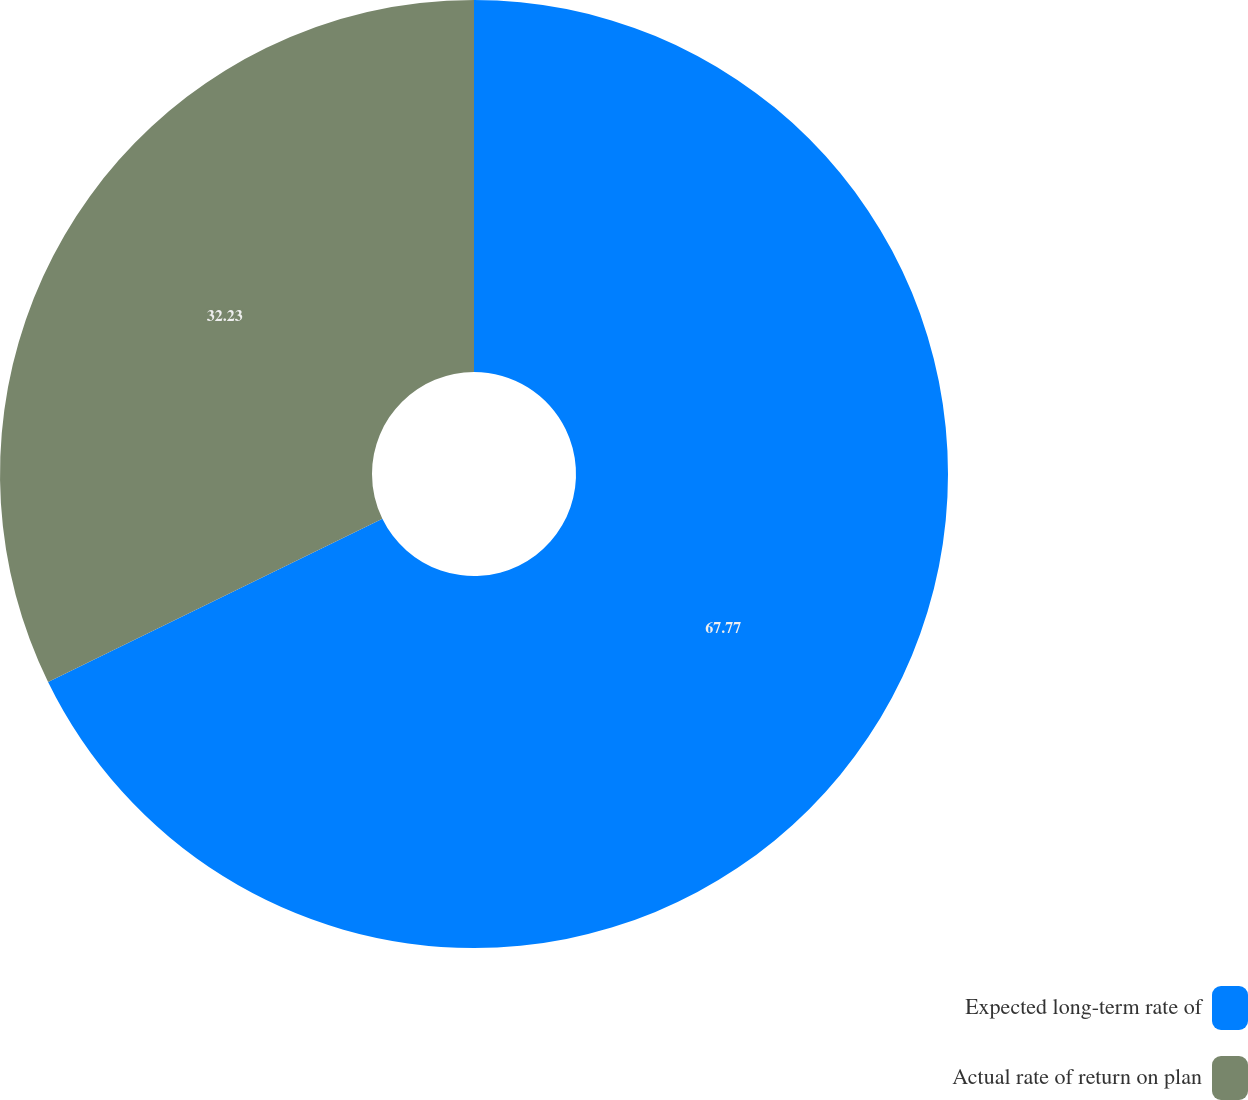Convert chart. <chart><loc_0><loc_0><loc_500><loc_500><pie_chart><fcel>Expected long-term rate of<fcel>Actual rate of return on plan<nl><fcel>67.77%<fcel>32.23%<nl></chart> 